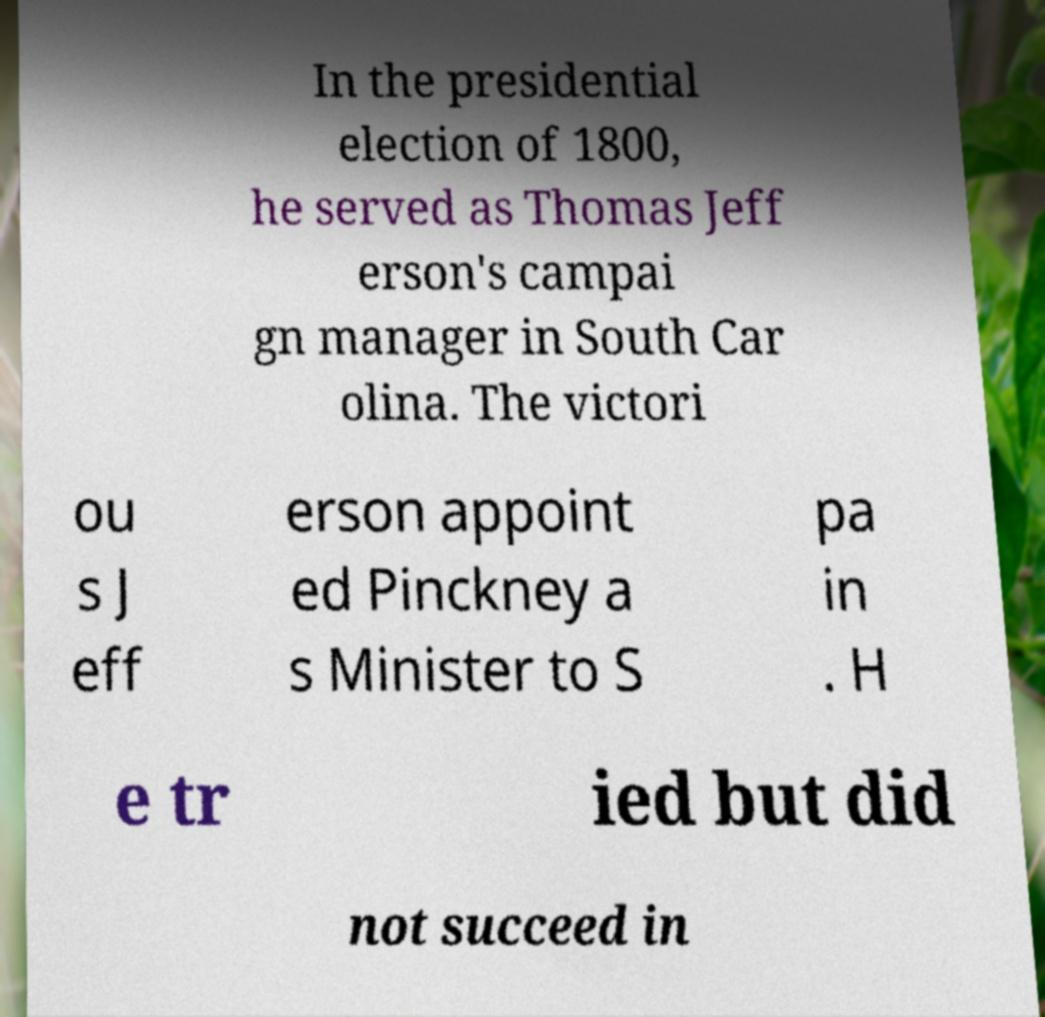Could you assist in decoding the text presented in this image and type it out clearly? In the presidential election of 1800, he served as Thomas Jeff erson's campai gn manager in South Car olina. The victori ou s J eff erson appoint ed Pinckney a s Minister to S pa in . H e tr ied but did not succeed in 